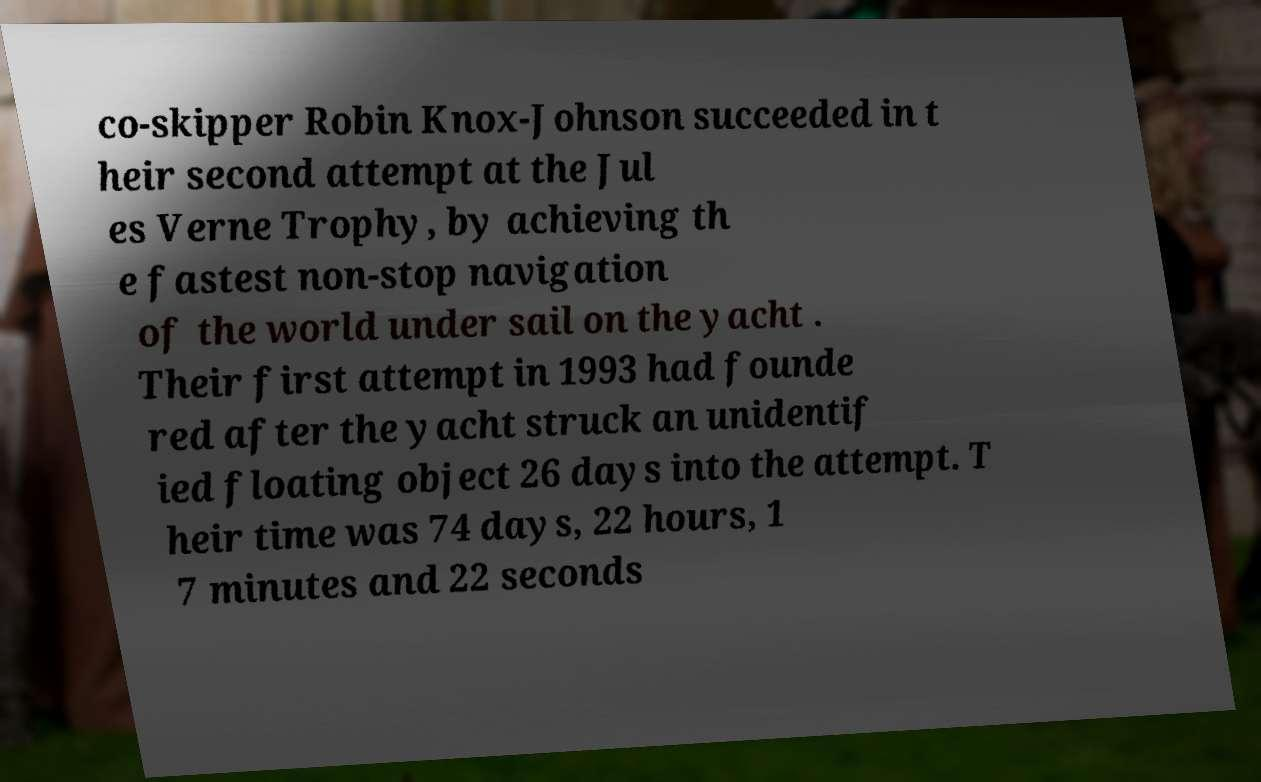Please read and relay the text visible in this image. What does it say? co-skipper Robin Knox-Johnson succeeded in t heir second attempt at the Jul es Verne Trophy, by achieving th e fastest non-stop navigation of the world under sail on the yacht . Their first attempt in 1993 had founde red after the yacht struck an unidentif ied floating object 26 days into the attempt. T heir time was 74 days, 22 hours, 1 7 minutes and 22 seconds 